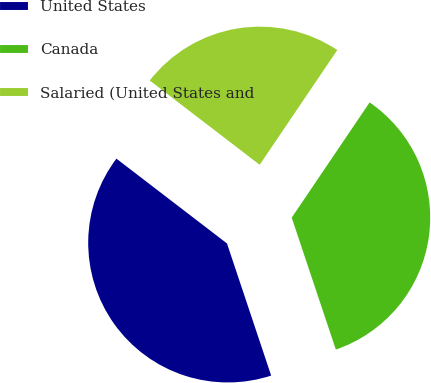Convert chart. <chart><loc_0><loc_0><loc_500><loc_500><pie_chart><fcel>United States<fcel>Canada<fcel>Salaried (United States and<nl><fcel>40.55%<fcel>35.4%<fcel>24.05%<nl></chart> 